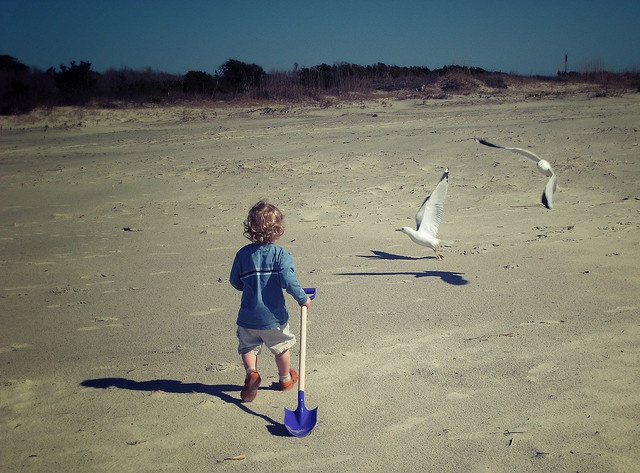Describe the objects in this image and their specific colors. I can see people in darkblue, navy, gray, and black tones, bird in darkblue, darkgray, ivory, lightgray, and gray tones, and bird in darkblue, darkgray, gray, and beige tones in this image. 